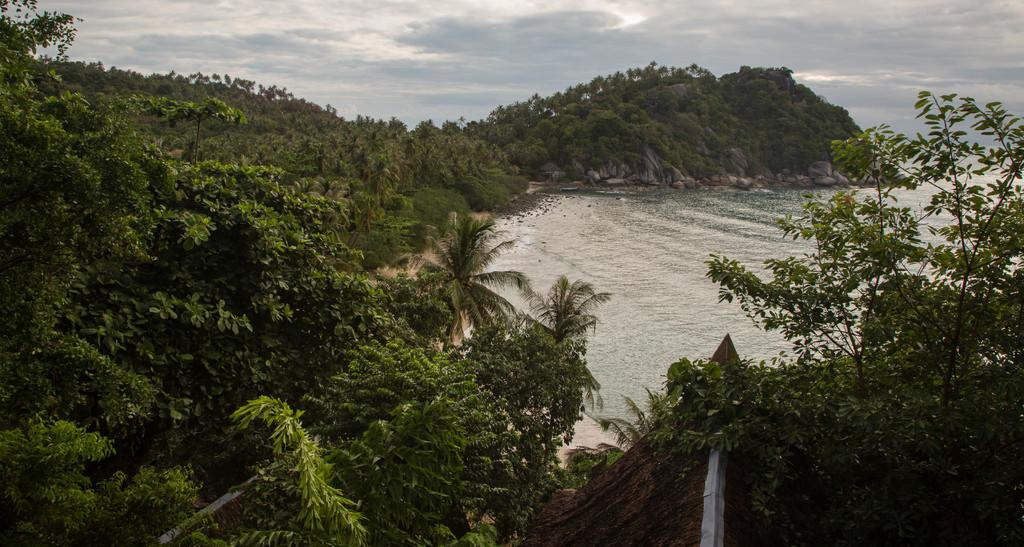What type of vegetation can be seen in the image? There are trees in the image. What part of a building can be seen in the image? The roof of a building is visible in the image. What natural element is present in the image? There is water visible in the image. What type of geological formation is in the background of the image? There are rocks in the background of the image. What large landform is in the background of the image? There is a mountain in the background of the image. What part of the sky is visible in the background of the image? The sky is visible in the background of the image. What type of market can be seen in the image? There is no market present in the image; it features trees, a building roof, water, rocks, a mountain, and the sky. What is the texture of the current in the image? There is no current present in the image, and therefore no texture can be determined. 